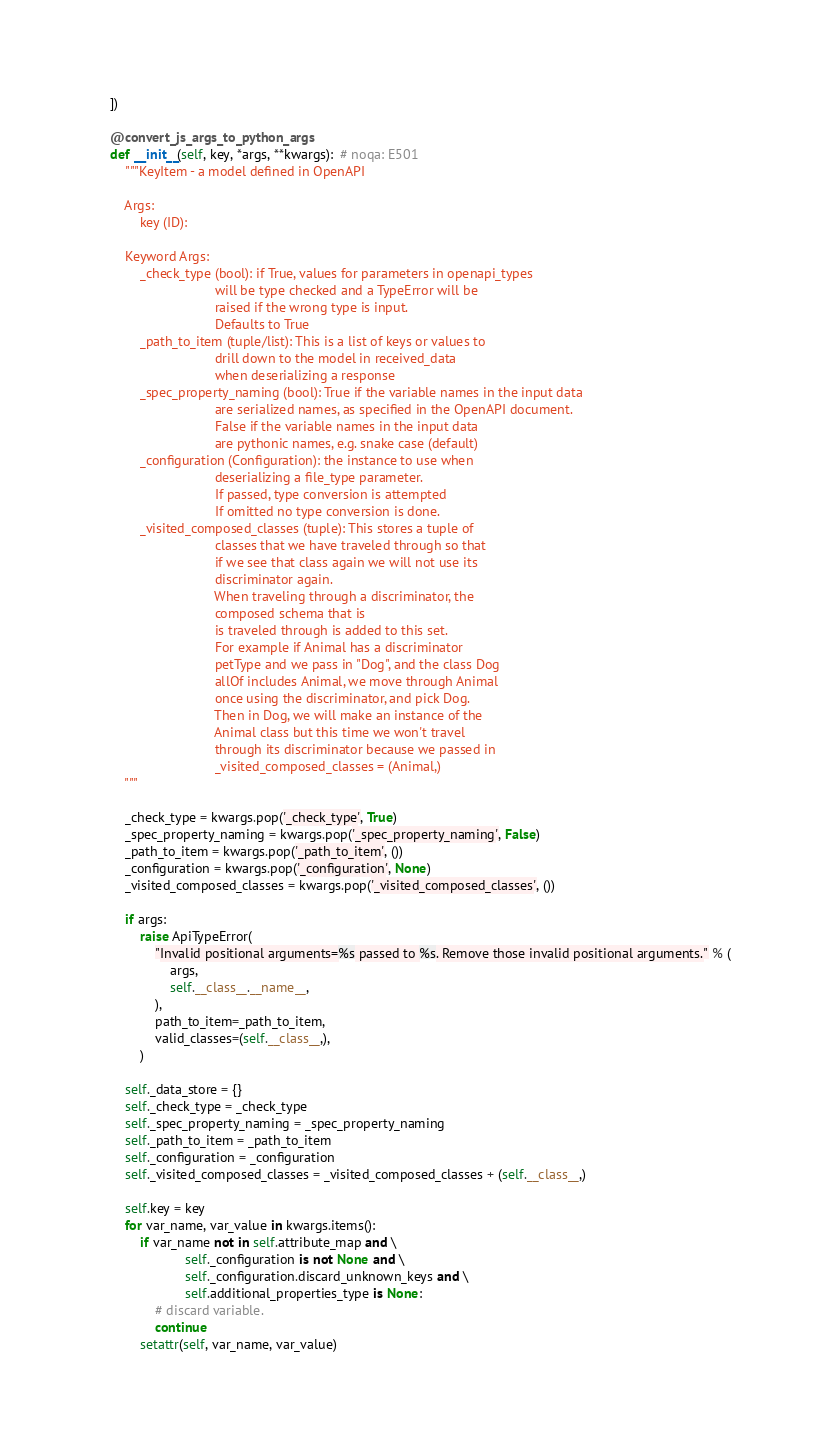Convert code to text. <code><loc_0><loc_0><loc_500><loc_500><_Python_>    ])

    @convert_js_args_to_python_args
    def __init__(self, key, *args, **kwargs):  # noqa: E501
        """KeyItem - a model defined in OpenAPI

        Args:
            key (ID):

        Keyword Args:
            _check_type (bool): if True, values for parameters in openapi_types
                                will be type checked and a TypeError will be
                                raised if the wrong type is input.
                                Defaults to True
            _path_to_item (tuple/list): This is a list of keys or values to
                                drill down to the model in received_data
                                when deserializing a response
            _spec_property_naming (bool): True if the variable names in the input data
                                are serialized names, as specified in the OpenAPI document.
                                False if the variable names in the input data
                                are pythonic names, e.g. snake case (default)
            _configuration (Configuration): the instance to use when
                                deserializing a file_type parameter.
                                If passed, type conversion is attempted
                                If omitted no type conversion is done.
            _visited_composed_classes (tuple): This stores a tuple of
                                classes that we have traveled through so that
                                if we see that class again we will not use its
                                discriminator again.
                                When traveling through a discriminator, the
                                composed schema that is
                                is traveled through is added to this set.
                                For example if Animal has a discriminator
                                petType and we pass in "Dog", and the class Dog
                                allOf includes Animal, we move through Animal
                                once using the discriminator, and pick Dog.
                                Then in Dog, we will make an instance of the
                                Animal class but this time we won't travel
                                through its discriminator because we passed in
                                _visited_composed_classes = (Animal,)
        """

        _check_type = kwargs.pop('_check_type', True)
        _spec_property_naming = kwargs.pop('_spec_property_naming', False)
        _path_to_item = kwargs.pop('_path_to_item', ())
        _configuration = kwargs.pop('_configuration', None)
        _visited_composed_classes = kwargs.pop('_visited_composed_classes', ())

        if args:
            raise ApiTypeError(
                "Invalid positional arguments=%s passed to %s. Remove those invalid positional arguments." % (
                    args,
                    self.__class__.__name__,
                ),
                path_to_item=_path_to_item,
                valid_classes=(self.__class__,),
            )

        self._data_store = {}
        self._check_type = _check_type
        self._spec_property_naming = _spec_property_naming
        self._path_to_item = _path_to_item
        self._configuration = _configuration
        self._visited_composed_classes = _visited_composed_classes + (self.__class__,)

        self.key = key
        for var_name, var_value in kwargs.items():
            if var_name not in self.attribute_map and \
                        self._configuration is not None and \
                        self._configuration.discard_unknown_keys and \
                        self.additional_properties_type is None:
                # discard variable.
                continue
            setattr(self, var_name, var_value)
</code> 